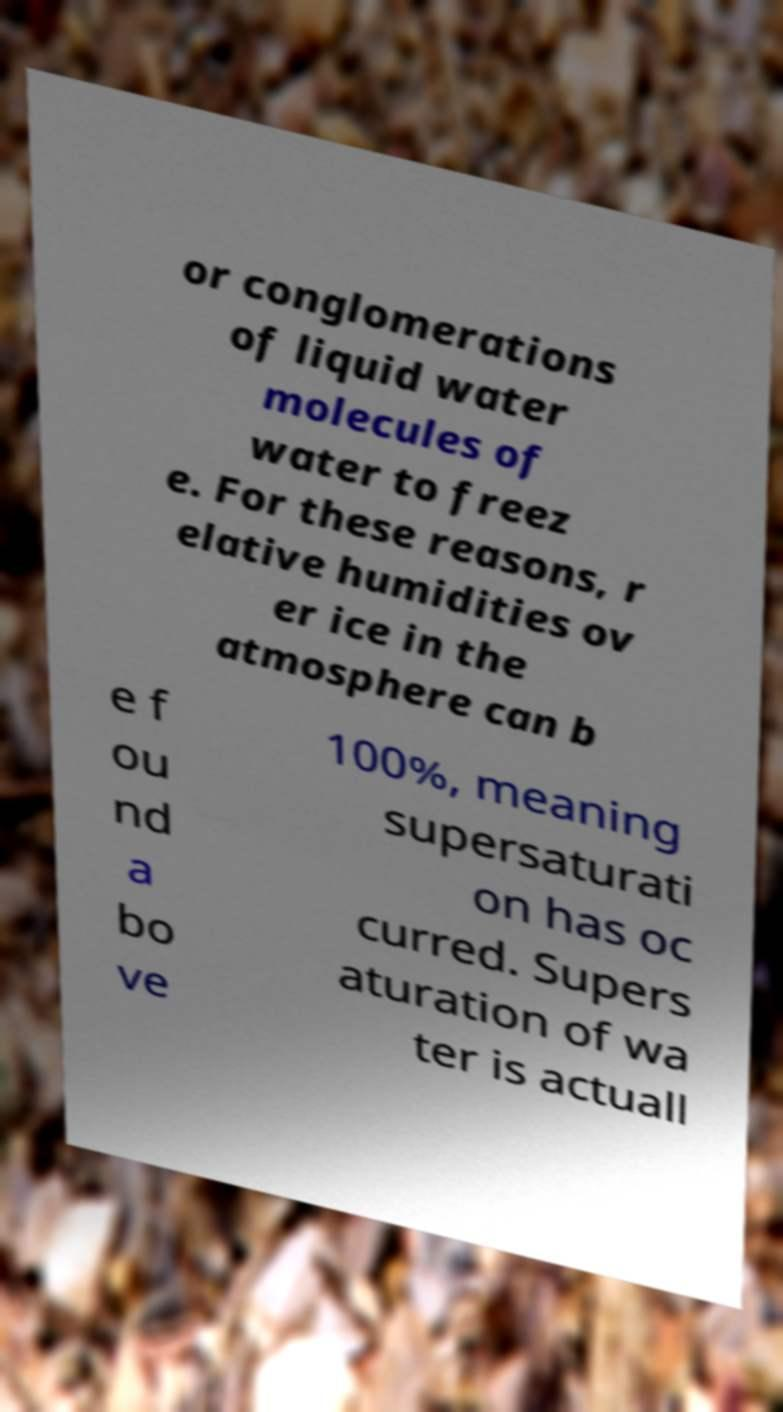Could you extract and type out the text from this image? or conglomerations of liquid water molecules of water to freez e. For these reasons, r elative humidities ov er ice in the atmosphere can b e f ou nd a bo ve 100%, meaning supersaturati on has oc curred. Supers aturation of wa ter is actuall 